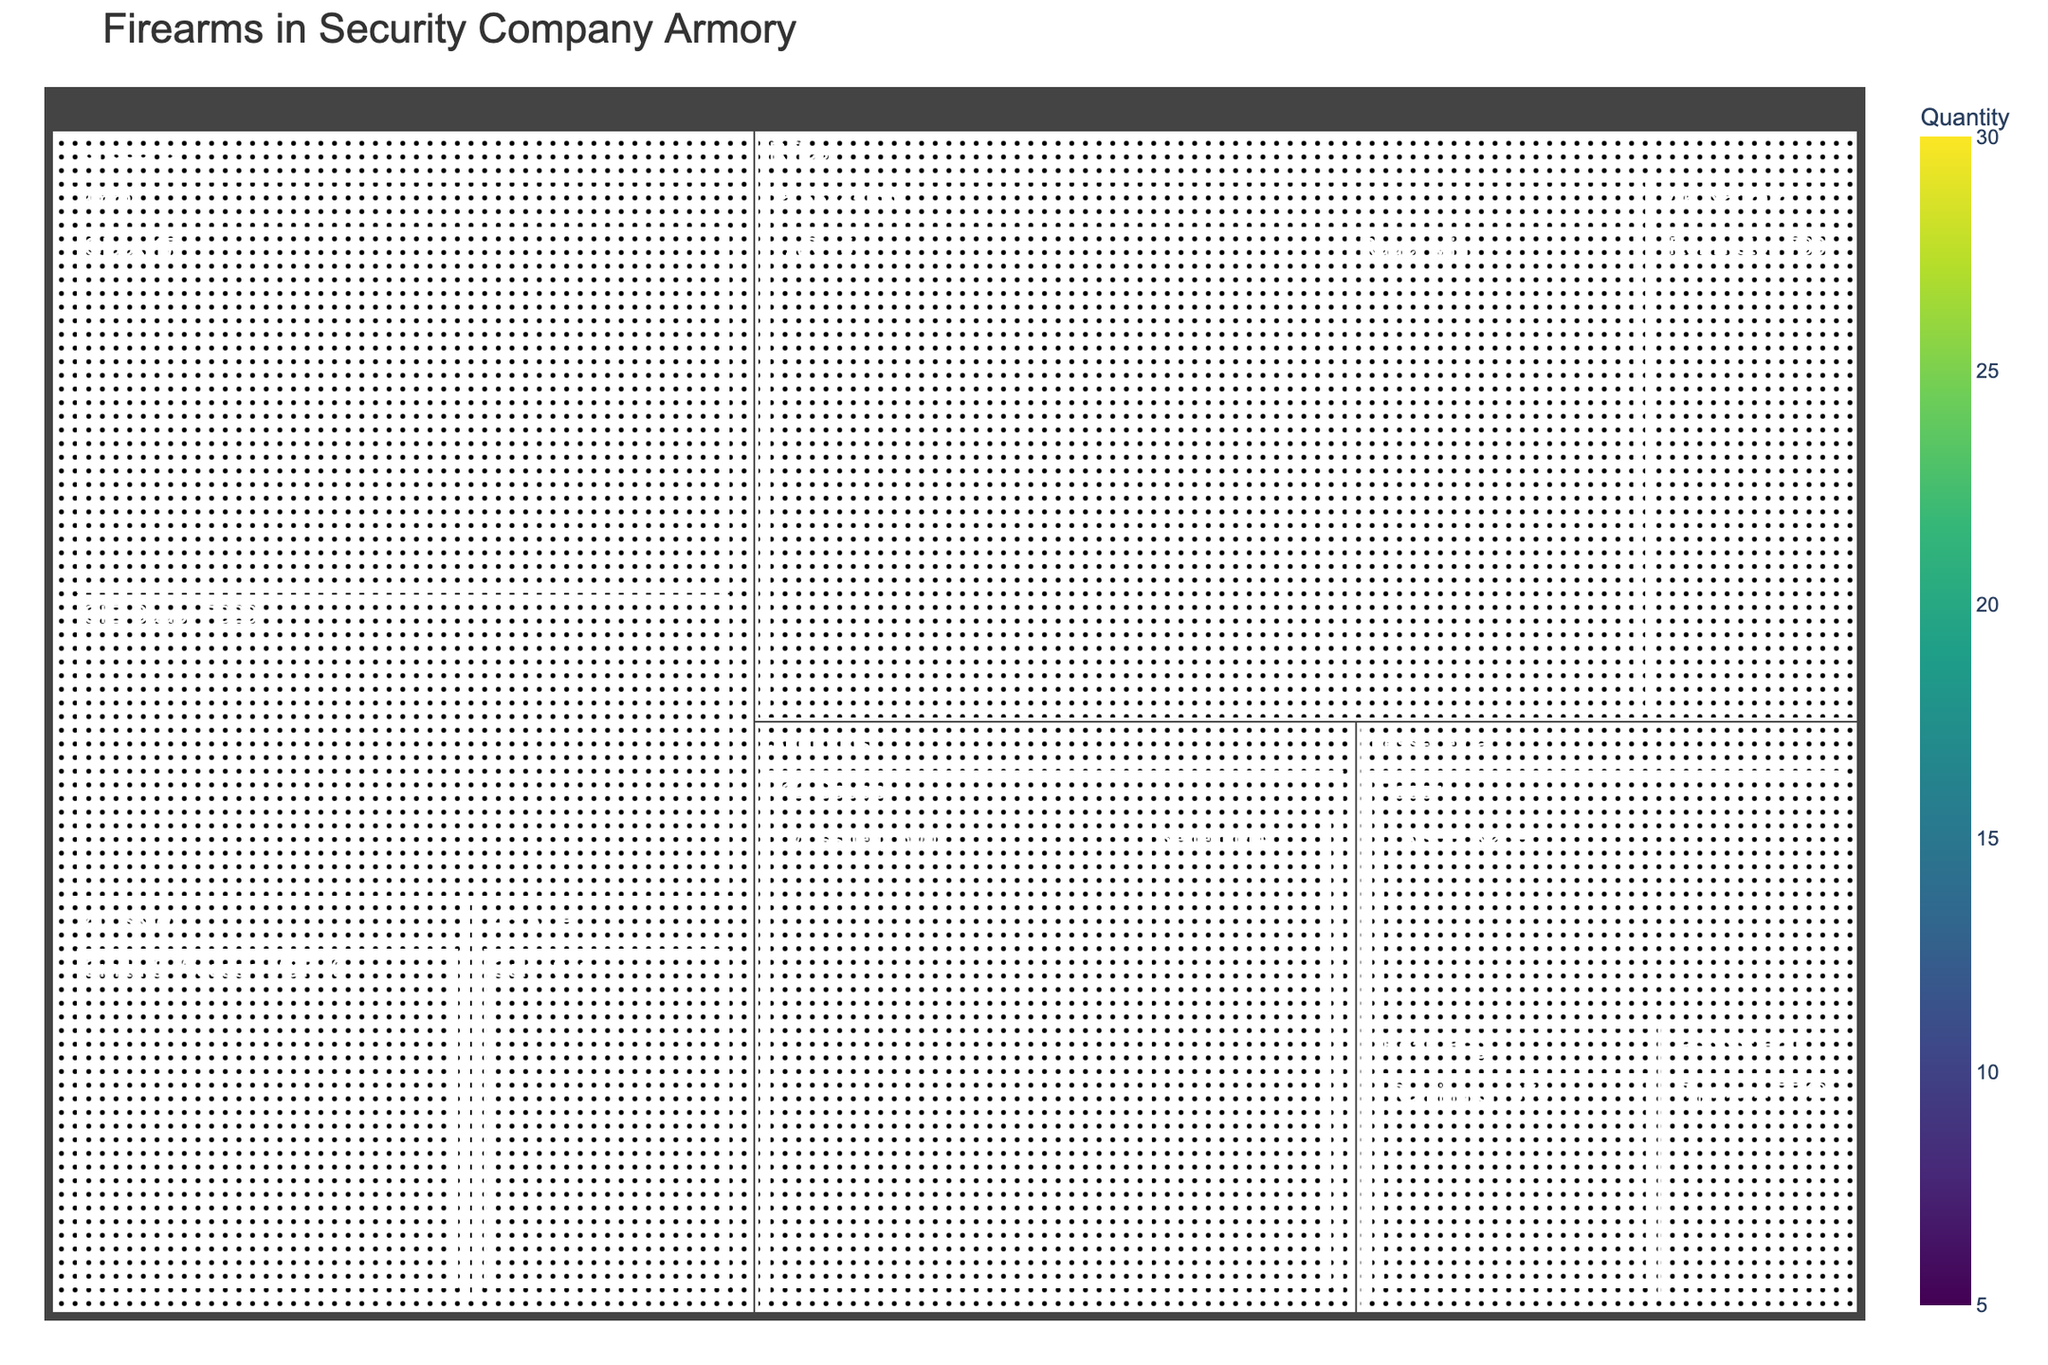What's the title of the figure? The title is usually prominently displayed at the top of the figure.
Answer: Firearms in Security Company Armory What is the category with the highest total number of firearms? To determine this, you need to sum the values of firearms for each category. By inspection, Handguns have 70, Rifles have 55, Shotguns have 30, and Less-Lethal have 25. Handguns have the highest total.
Answer: Handguns How many 9mm handguns are there? Look at the subcategory 9mm under Handguns. The values for Glock 17 and SIG Sauer P320 are 25 and 20, respectively. Summing these gives 45.
Answer: 45 Which rifle model has the highest number of firearms? Compare the numbers under the Rifles category: AR-15 (30), Ruger Mini-14 (15), and Remington 700 (10). AR-15 has the highest number.
Answer: AR-15 What is the total number of Less-Lethal firearms? Add the values of all firearms in the Less-Lethal category. Remington 870 (8), Tippmann FT-12 (5), and TASER X26P (12). The total is 8 + 5 + 12.
Answer: 25 Which category has more firearms: Shotguns or Less-Lethal? Compare the totals for Shotguns (Mossberg 500: 20, Benelli M4: 10, total 30) and Less-Lethal (Remington 870: 8, Tippmann FT-12: 5, TASER X26P: 12, total 25). Shotguns have more firearms.
Answer: Shotguns What's the overall total number of firearms across all categories? Sum all values from all categories. Handguns (70), Rifles (55), Shotguns (30), Less-Lethal (25). The total is 70 + 55 + 30 + 25.
Answer: 180 Within the Handguns category, which caliber has the most firearms? Check the sum of values for each caliber under Handguns: 9mm (45), .40 S&W (15), .45 ACP (10). 9mm has the most firearms.
Answer: 9mm Are there more 5.56x45mm or 7.62x51mm rifles? Compare the totals for these subcategories. 5.56x45mm (AR-15: 30, Ruger Mini-14: 15, total 45) and 7.62x51mm (Remington 700: 10). There are more 5.56x45mm rifles.
Answer: 5.56x45mm What's the least common firearm in the entire armory? Finding the smallest individual value among all firearms listed, which is Tippmann FT-12 with 5.
Answer: Tippmann FT-12 